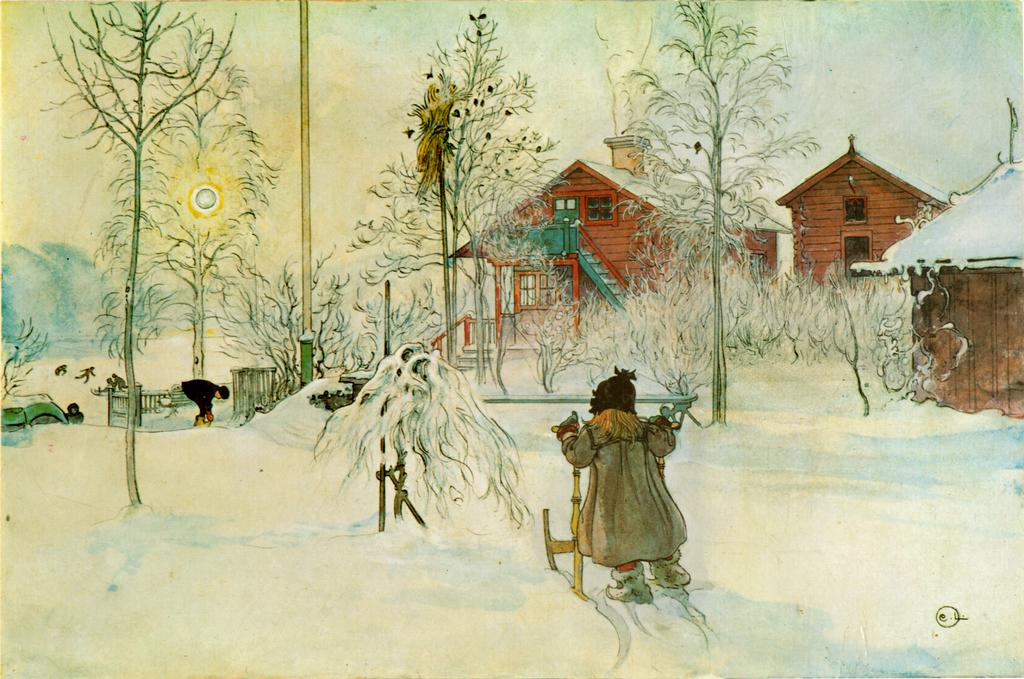What is depicted on the drawing poster in the image? The image contains a drawing poster of a girl. What is the girl standing on in the image? The girl is standing in the snow. What can be seen in the background of the image? There are trees and brown-colored houses visible in the background. What type of meat can be seen hanging from the trees in the image? There is no meat visible in the image; the trees are in the background of a drawing poster of a girl standing in the snow. Are there any bees buzzing around the girl in the image? There is no mention of bees in the image, which only features a drawing poster of a girl standing in the snow with trees and brown-colored houses in the background. 